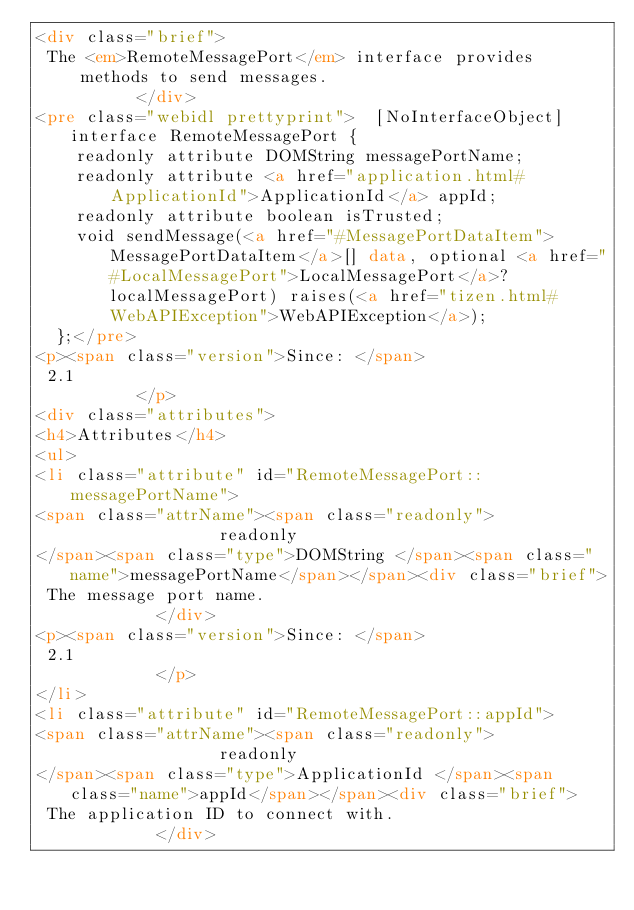<code> <loc_0><loc_0><loc_500><loc_500><_HTML_><div class="brief">
 The <em>RemoteMessagePort</em> interface provides methods to send messages.
          </div>
<pre class="webidl prettyprint">  [NoInterfaceObject] interface RemoteMessagePort {
    readonly attribute DOMString messagePortName;
    readonly attribute <a href="application.html#ApplicationId">ApplicationId</a> appId;
    readonly attribute boolean isTrusted;
    void sendMessage(<a href="#MessagePortDataItem">MessagePortDataItem</a>[] data, optional <a href="#LocalMessagePort">LocalMessagePort</a>? localMessagePort) raises(<a href="tizen.html#WebAPIException">WebAPIException</a>);
  };</pre>
<p><span class="version">Since: </span>
 2.1
          </p>
<div class="attributes">
<h4>Attributes</h4>
<ul>
<li class="attribute" id="RemoteMessagePort::messagePortName">
<span class="attrName"><span class="readonly">                readonly
</span><span class="type">DOMString </span><span class="name">messagePortName</span></span><div class="brief">
 The message port name.
            </div>
<p><span class="version">Since: </span>
 2.1
            </p>
</li>
<li class="attribute" id="RemoteMessagePort::appId">
<span class="attrName"><span class="readonly">                readonly
</span><span class="type">ApplicationId </span><span class="name">appId</span></span><div class="brief">
 The application ID to connect with.
            </div></code> 